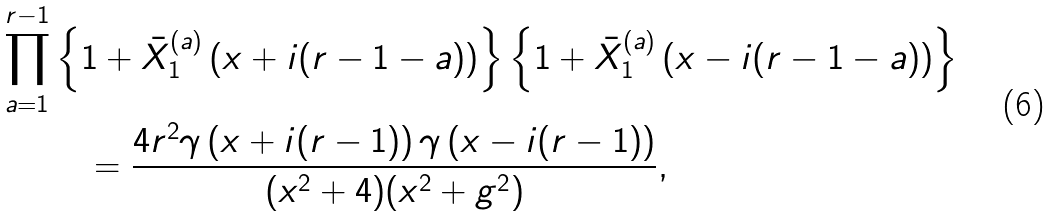Convert formula to latex. <formula><loc_0><loc_0><loc_500><loc_500>\prod _ { a = 1 } ^ { r - 1 } & \left \{ 1 + \bar { X } ^ { ( a ) } _ { 1 } \left ( x + i ( r - 1 - a ) \right ) \right \} \left \{ 1 + \bar { X } ^ { ( a ) } _ { 1 } \left ( x - i ( r - 1 - a ) \right ) \right \} \\ & \quad = \frac { 4 r ^ { 2 } \gamma \left ( x + i ( r - 1 ) \right ) \gamma \left ( x - i ( r - 1 ) \right ) } { ( x ^ { 2 } + 4 ) ( x ^ { 2 } + g ^ { 2 } ) } ,</formula> 